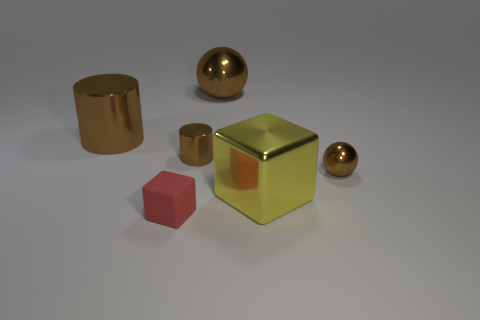Subtract all red blocks. How many blocks are left? 1 Add 1 small matte cubes. How many objects exist? 7 Add 2 tiny brown cylinders. How many tiny brown cylinders are left? 3 Add 1 big brown cylinders. How many big brown cylinders exist? 2 Subtract 0 green balls. How many objects are left? 6 Subtract all cylinders. How many objects are left? 4 Subtract 1 balls. How many balls are left? 1 Subtract all yellow cubes. Subtract all purple cylinders. How many cubes are left? 1 Subtract all brown cubes. How many green balls are left? 0 Subtract all tiny matte objects. Subtract all tiny purple matte cubes. How many objects are left? 5 